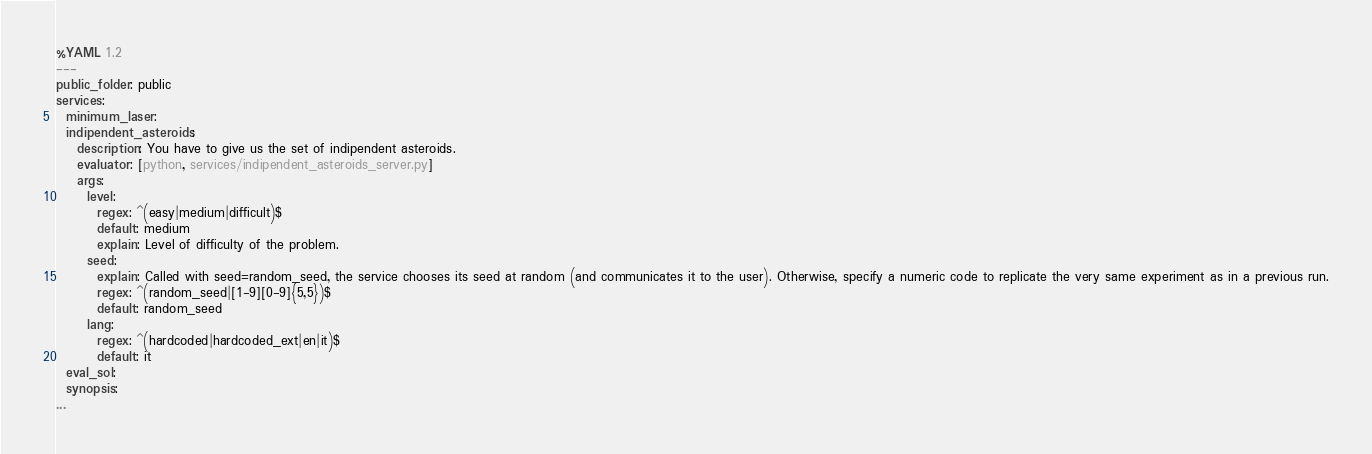Convert code to text. <code><loc_0><loc_0><loc_500><loc_500><_YAML_>%YAML 1.2
---
public_folder: public
services:
  minimum_laser:
  indipendent_asteroids:
    description: You have to give us the set of indipendent asteroids.
    evaluator: [python, services/indipendent_asteroids_server.py]
    args:
      level:
        regex: ^(easy|medium|difficult)$
        default: medium
        explain: Level of difficulty of the problem.
      seed:
        explain: Called with seed=random_seed, the service chooses its seed at random (and communicates it to the user). Otherwise, specify a numeric code to replicate the very same experiment as in a previous run.
        regex: ^(random_seed|[1-9][0-9]{5,5})$
        default: random_seed
      lang:
        regex: ^(hardcoded|hardcoded_ext|en|it)$
        default: it
  eval_sol:
  synopsis:
...
</code> 